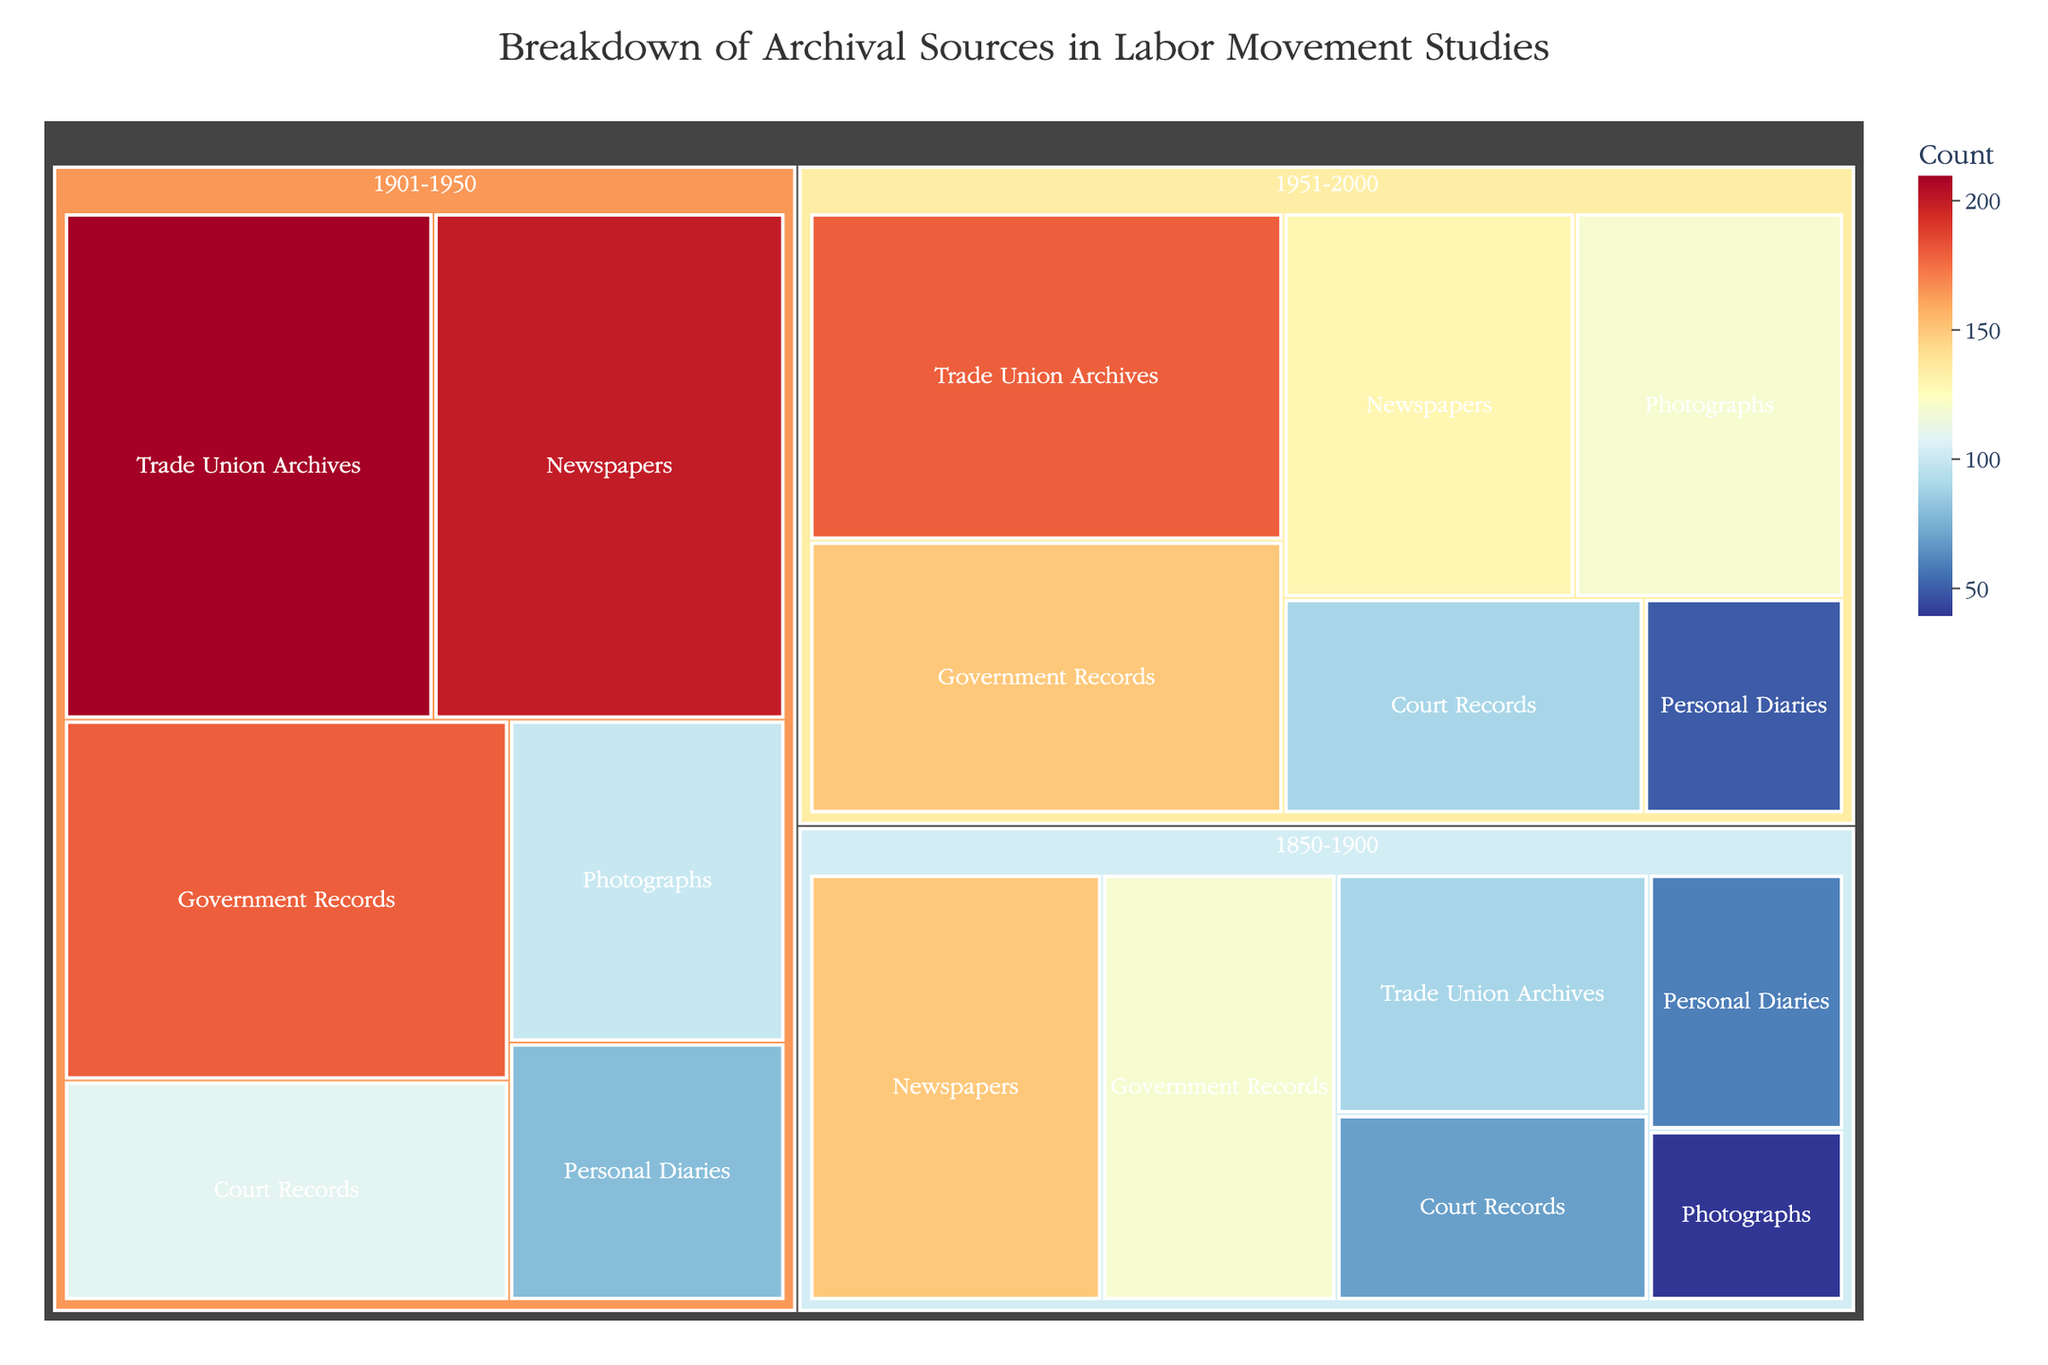What's the total count of Government Records from 1850-2000? Add up the counts for Government Records from each period (120 + 180 + 150)
Answer: 450 Which archival source type has the highest count in the period 1901-1950? Compare the counts of all archival source types in the 1901-1950 period. The counts are: Government Records (180), Trade Union Archives (210), Newspapers (200), Personal Diaries (80), Photographs (100), Court Records (110). The highest is Trade Union Archives with 210.
Answer: Trade Union Archives Between which two consecutive periods did the count for Newspapers decrease the most? Calculate the differences in Newspaper counts between consecutive periods: (200 - 150 = 50 from 1850-1900 to 1901-1950), (130 - 200 = -70 from 1901-1950 to 1951-2000). The greatest decrease is between 1901-1950 and 1951-2000.
Answer: 1901-1950 and 1951-2000 Which type of archival source had the smallest total count across all periods? Sum the counts for each type across all periods and compare: Government Records (450), Trade Union Archives (480), Newspapers (480), Personal Diaries (190), Photographs (260), Court Records (270). Personal Diaries have the smallest total count.
Answer: Personal Diaries How does the count of Photographs in 1951-2000 compare to Personal Diaries in the same period? Compare the counts of Photographs (120) and Personal Diaries (50) in the 1951-2000 period. Photographs have a higher count.
Answer: Photographs have a higher count than Personal Diaries What is the average count of Trade Union Archives across all periods? Add up the counts for Trade Union Archives (90 + 210 + 180) and divide by the number of periods (3): (90 + 210 + 180) / 3 = 160
Answer: 160 Is there any period where the count of Government Records surpasses that of Newspapers? Check the counts of Government Records and Newspapers in each period: 1850-1900: GR (120) < NP (150); 1901-1950: GR (180) < NP (200); 1951-2000: GR (150) > NP (130). Thus, only in 1951-2000 does the count of Government Records surpass that of Newspapers.
Answer: Yes, in 1951-2000 What is the collective count of archival sources in 1850-1900? Sum the counts of all types in the 1850-1900 period: Government Records (120), Trade Union Archives (90), Newspapers (150), Personal Diaries (60), Photographs (40), Court Records (70). Total is 120 + 90 + 150 + 60 + 40 + 70 = 530
Answer: 530 How many types of archival sources have a count greater than 100 in any period from 1850-2000? Count the number of types with any period count > 100: Government Records (1850-1900: No, 1901-1950: Yes, 1951-2000: Yes); Trade Union Archives (1850-1900: No, 1901-1950: Yes, 1951-2000: Yes); Newspapers (1850-1900: Yes, 1901-1950: Yes, 1951-2000: Yes); Personal Diaries (No); Photographs (1951-2000: Yes); Court Records (1901-1950: Yes). Total types: 5 (Government Records, Trade Union Archives, Newspapers, Photographs, Court Records).
Answer: 5 Which period shows the highest total count for archival sources? Sum the counts for each period: 1850-1900: 530, 1901-1950: 880, 1951-2000: 720. The highest total is in 1901-1950 with 880.
Answer: 1901-1950 